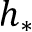Convert formula to latex. <formula><loc_0><loc_0><loc_500><loc_500>h _ { * }</formula> 